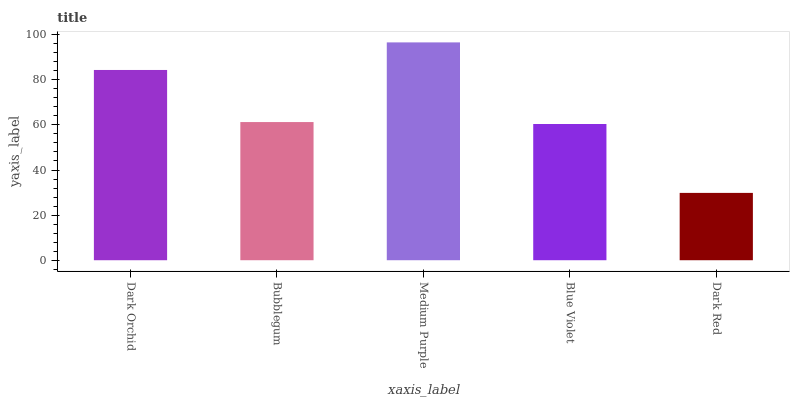Is Dark Red the minimum?
Answer yes or no. Yes. Is Medium Purple the maximum?
Answer yes or no. Yes. Is Bubblegum the minimum?
Answer yes or no. No. Is Bubblegum the maximum?
Answer yes or no. No. Is Dark Orchid greater than Bubblegum?
Answer yes or no. Yes. Is Bubblegum less than Dark Orchid?
Answer yes or no. Yes. Is Bubblegum greater than Dark Orchid?
Answer yes or no. No. Is Dark Orchid less than Bubblegum?
Answer yes or no. No. Is Bubblegum the high median?
Answer yes or no. Yes. Is Bubblegum the low median?
Answer yes or no. Yes. Is Dark Red the high median?
Answer yes or no. No. Is Dark Orchid the low median?
Answer yes or no. No. 